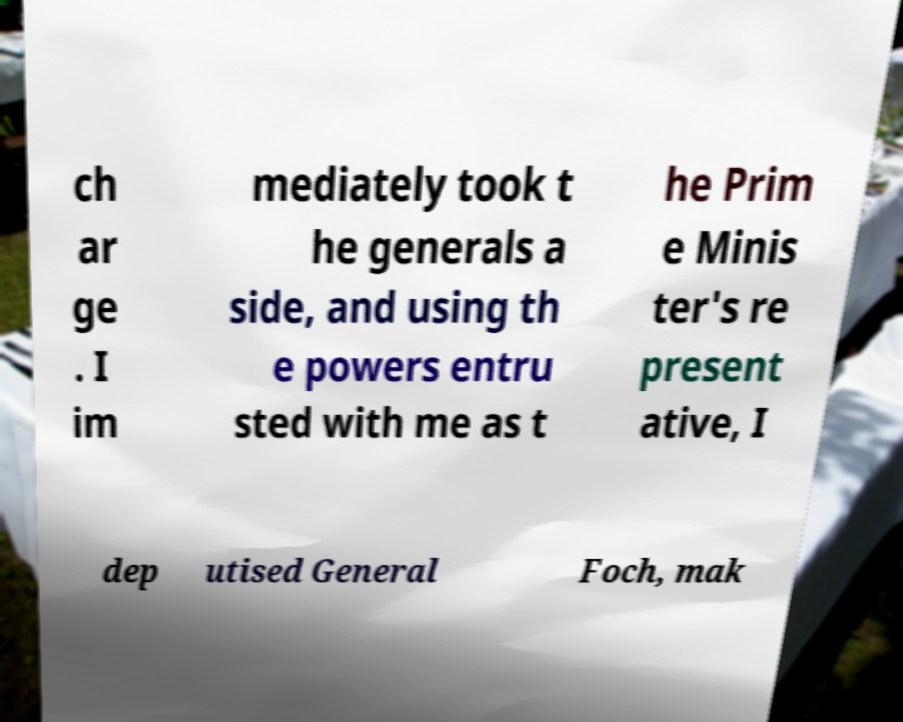Please read and relay the text visible in this image. What does it say? ch ar ge . I im mediately took t he generals a side, and using th e powers entru sted with me as t he Prim e Minis ter's re present ative, I dep utised General Foch, mak 